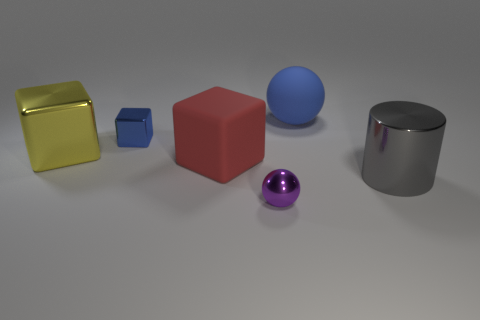What is the shape of the large red thing?
Provide a succinct answer. Cube. There is a big red object; is it the same shape as the metallic thing in front of the large cylinder?
Provide a short and direct response. No. There is a matte object on the right side of the small purple sphere; does it have the same shape as the red thing?
Your answer should be very brief. No. How many blue things are both on the right side of the purple metal thing and on the left side of the red matte block?
Your answer should be compact. 0. What number of other objects are there of the same size as the purple metal ball?
Provide a short and direct response. 1. Is the number of matte cubes that are behind the matte sphere the same as the number of cyan matte balls?
Your answer should be compact. Yes. There is a metal thing that is behind the big metal cube; is it the same color as the small object that is in front of the gray cylinder?
Give a very brief answer. No. The thing that is on the right side of the small metallic ball and on the left side of the large gray shiny thing is made of what material?
Your answer should be compact. Rubber. The big metal cylinder is what color?
Keep it short and to the point. Gray. How many other objects are there of the same shape as the large blue rubber object?
Your answer should be very brief. 1. 